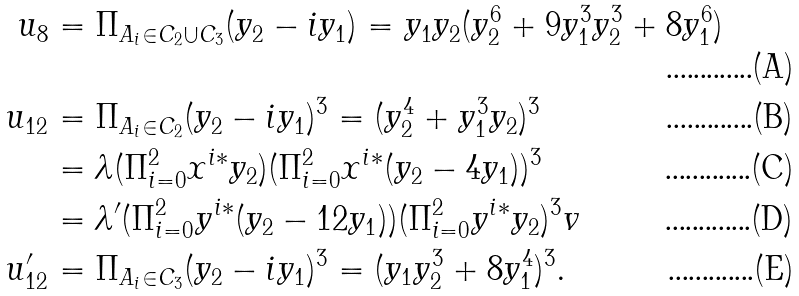<formula> <loc_0><loc_0><loc_500><loc_500>u _ { 8 } & = \Pi _ { A _ { i } \in C _ { 2 } \cup C _ { 3 } } ( y _ { 2 } - i y _ { 1 } ) = y _ { 1 } y _ { 2 } ( y _ { 2 } ^ { 6 } + 9 y _ { 1 } ^ { 3 } y _ { 2 } ^ { 3 } + 8 y _ { 1 } ^ { 6 } ) \\ u _ { 1 2 } & = \Pi _ { A _ { i } \in C _ { 2 } } ( y _ { 2 } - i y _ { 1 } ) ^ { 3 } = ( y _ { 2 } ^ { 4 } + y _ { 1 } ^ { 3 } y _ { 2 } ) ^ { 3 } \\ & = \lambda ( \Pi _ { i = 0 } ^ { 2 } x ^ { i * } y _ { 2 } ) ( \Pi _ { i = 0 } ^ { 2 } x ^ { i * } ( y _ { 2 } - 4 y _ { 1 } ) ) ^ { 3 } \\ & = \lambda ^ { \prime } ( \Pi _ { i = 0 } ^ { 2 } y ^ { i * } ( y _ { 2 } - 1 2 y _ { 1 } ) ) ( \Pi _ { i = 0 } ^ { 2 } y ^ { i * } y _ { 2 } ) ^ { 3 } v \\ u _ { 1 2 } ^ { \prime } & = \Pi _ { A _ { i } \in C _ { 3 } } ( y _ { 2 } - i y _ { 1 } ) ^ { 3 } = ( y _ { 1 } y _ { 2 } ^ { 3 } + 8 y _ { 1 } ^ { 4 } ) ^ { 3 } .</formula> 